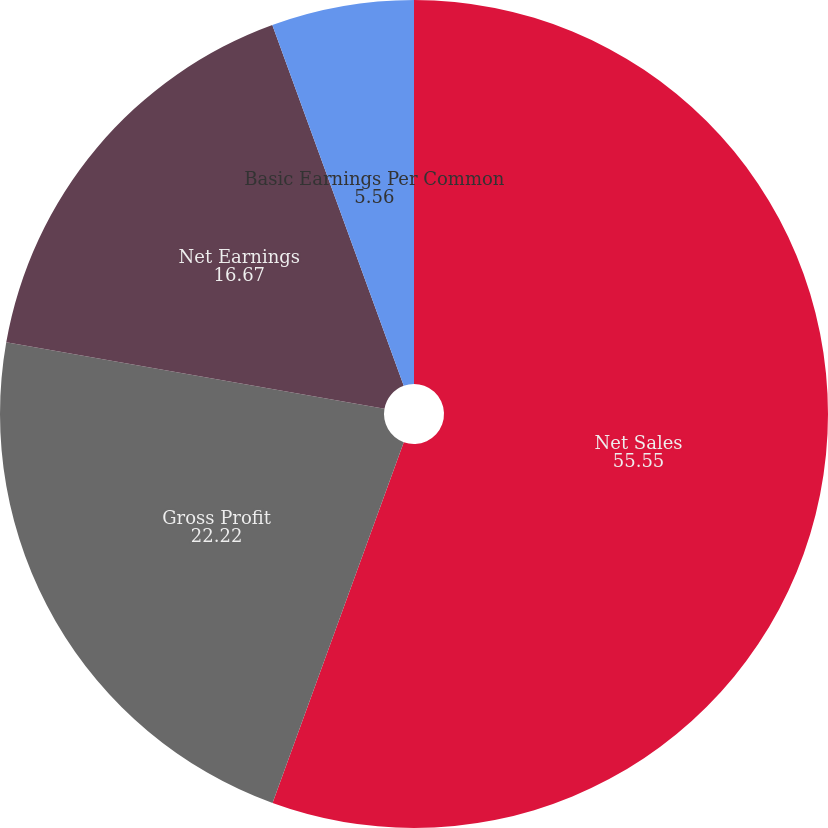Convert chart. <chart><loc_0><loc_0><loc_500><loc_500><pie_chart><fcel>Net Sales<fcel>Gross Profit<fcel>Net Earnings<fcel>Basic Earnings Per Common<fcel>Diluted Earnings Per Common<nl><fcel>55.55%<fcel>22.22%<fcel>16.67%<fcel>5.56%<fcel>0.0%<nl></chart> 